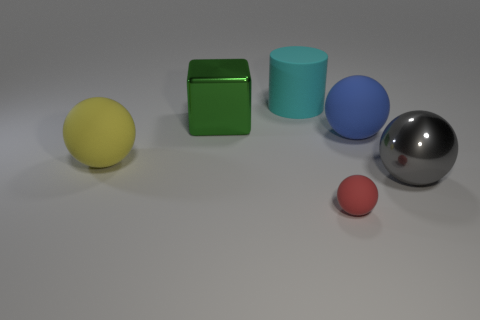Is there any other thing that has the same size as the red object?
Ensure brevity in your answer.  No. How big is the rubber sphere that is in front of the metallic thing that is right of the big green object?
Offer a terse response. Small. What color is the large ball that is to the left of the big shiny thing to the left of the rubber sphere on the right side of the small object?
Offer a terse response. Yellow. There is a rubber sphere that is both on the left side of the blue matte thing and to the right of the big cylinder; what is its size?
Provide a succinct answer. Small. How many other things are there of the same shape as the gray object?
Your answer should be very brief. 3. How many cylinders are small yellow things or small objects?
Keep it short and to the point. 0. There is a metal thing that is to the left of the tiny thing in front of the gray object; is there a large green shiny thing behind it?
Make the answer very short. No. There is another tiny rubber thing that is the same shape as the yellow rubber object; what color is it?
Your answer should be compact. Red. What number of yellow things are either small things or matte balls?
Your response must be concise. 1. There is a large thing that is behind the big metal thing that is behind the shiny ball; what is its material?
Provide a succinct answer. Rubber. 